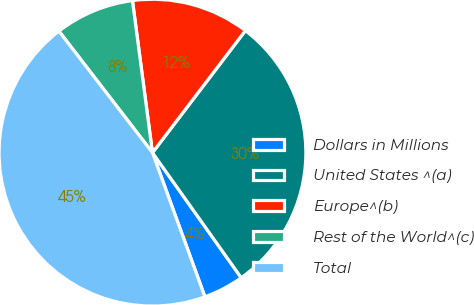<chart> <loc_0><loc_0><loc_500><loc_500><pie_chart><fcel>Dollars in Millions<fcel>United States ^(a)<fcel>Europe^(b)<fcel>Rest of the World^(c)<fcel>Total<nl><fcel>4.27%<fcel>29.82%<fcel>12.44%<fcel>8.36%<fcel>45.12%<nl></chart> 